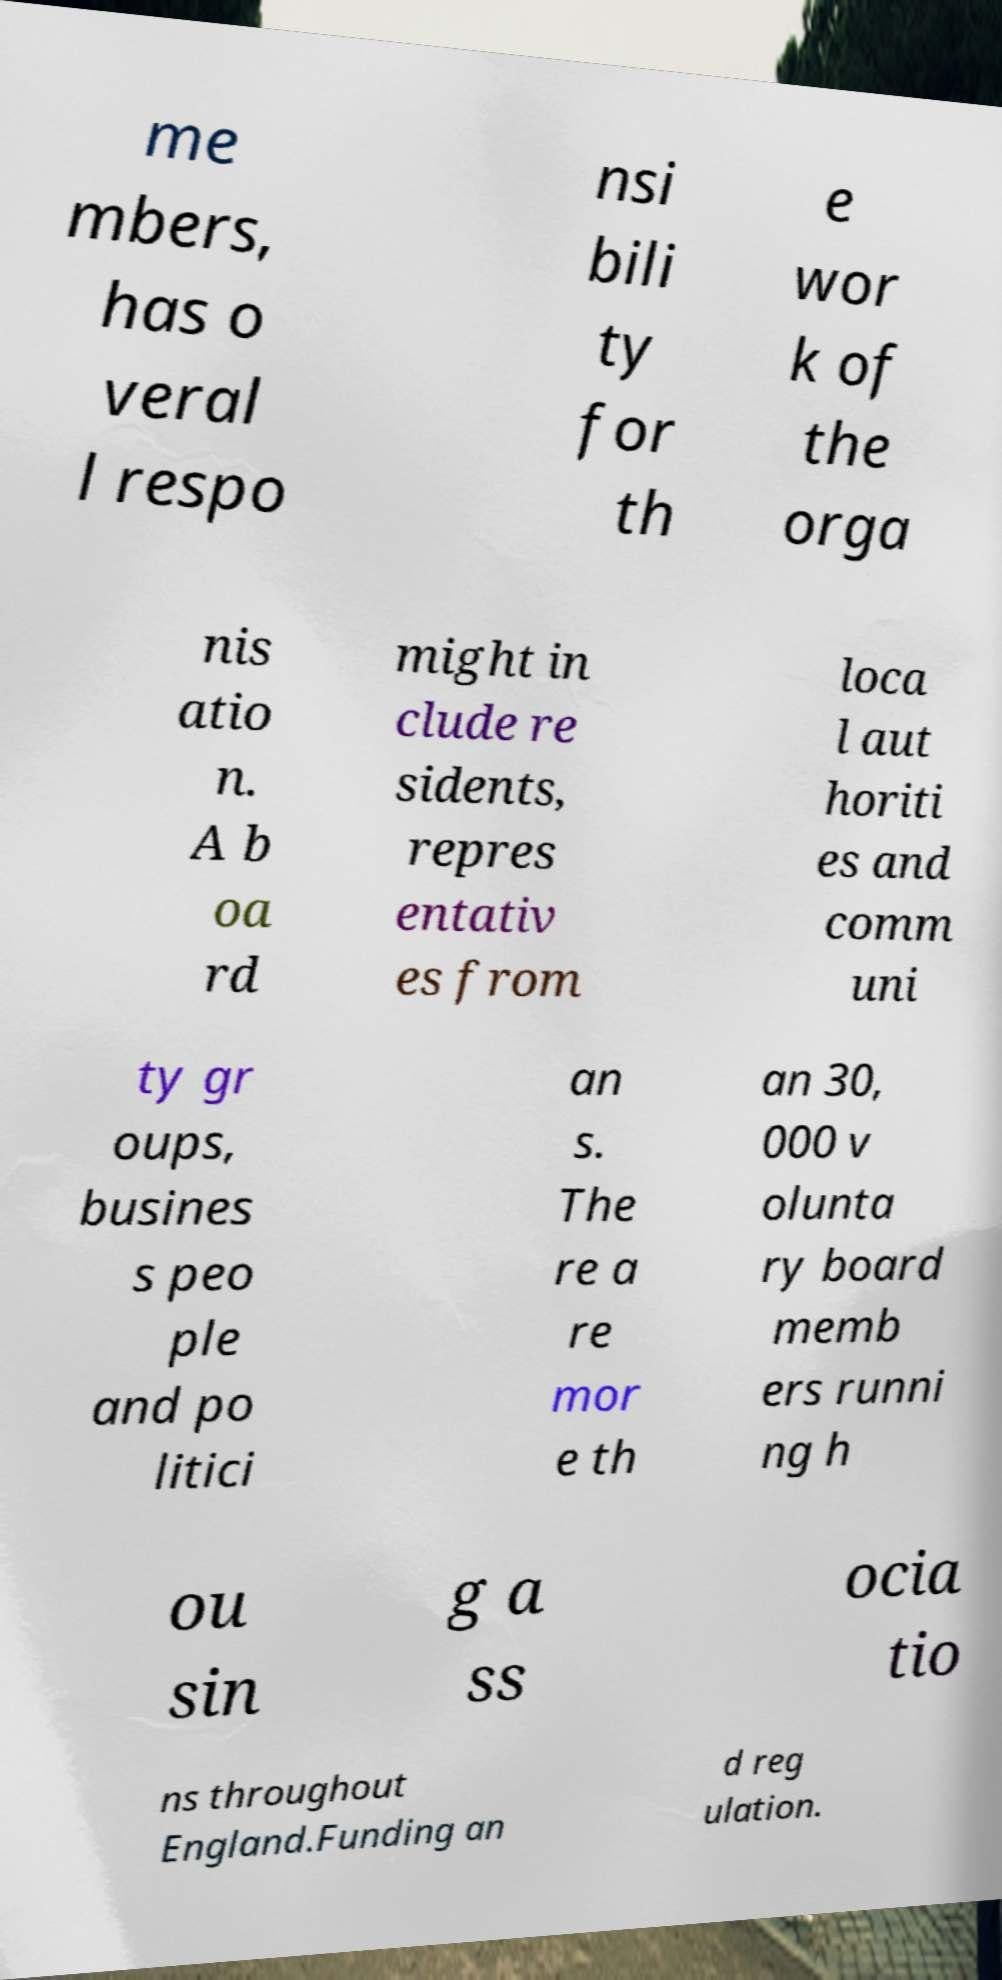Could you extract and type out the text from this image? me mbers, has o veral l respo nsi bili ty for th e wor k of the orga nis atio n. A b oa rd might in clude re sidents, repres entativ es from loca l aut horiti es and comm uni ty gr oups, busines s peo ple and po litici an s. The re a re mor e th an 30, 000 v olunta ry board memb ers runni ng h ou sin g a ss ocia tio ns throughout England.Funding an d reg ulation. 